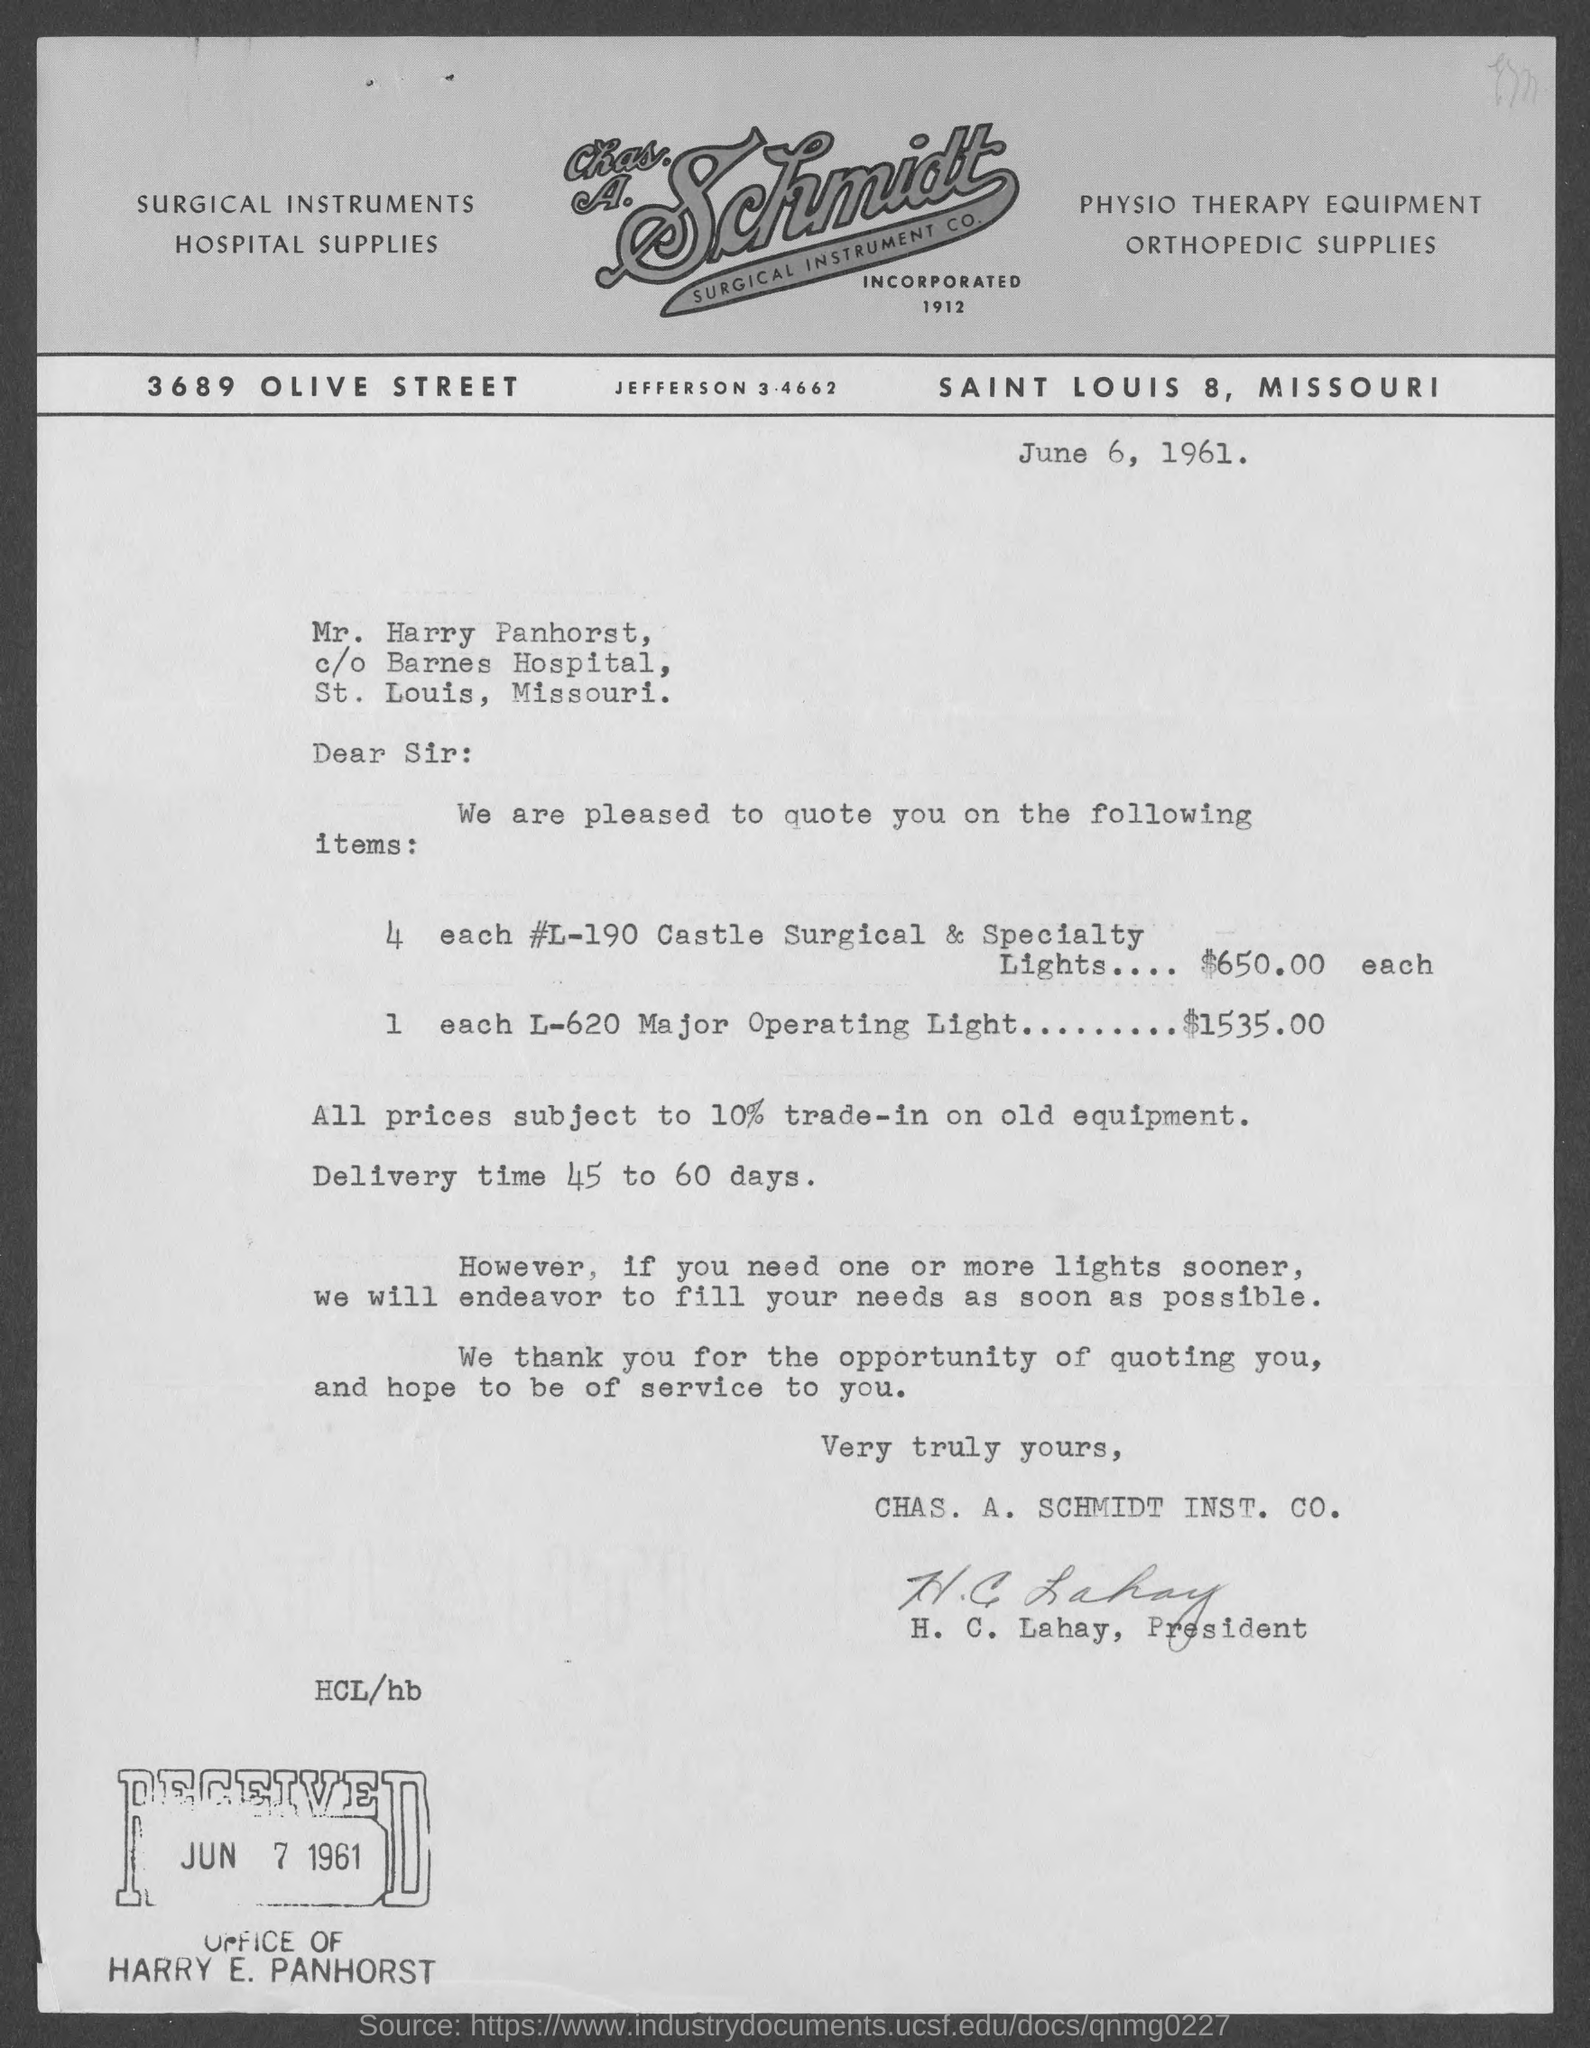When is the document dated?
Ensure brevity in your answer.  June 6, 1961. What is the delivery time?
Offer a very short reply. 45 TO 60 DAYS. 